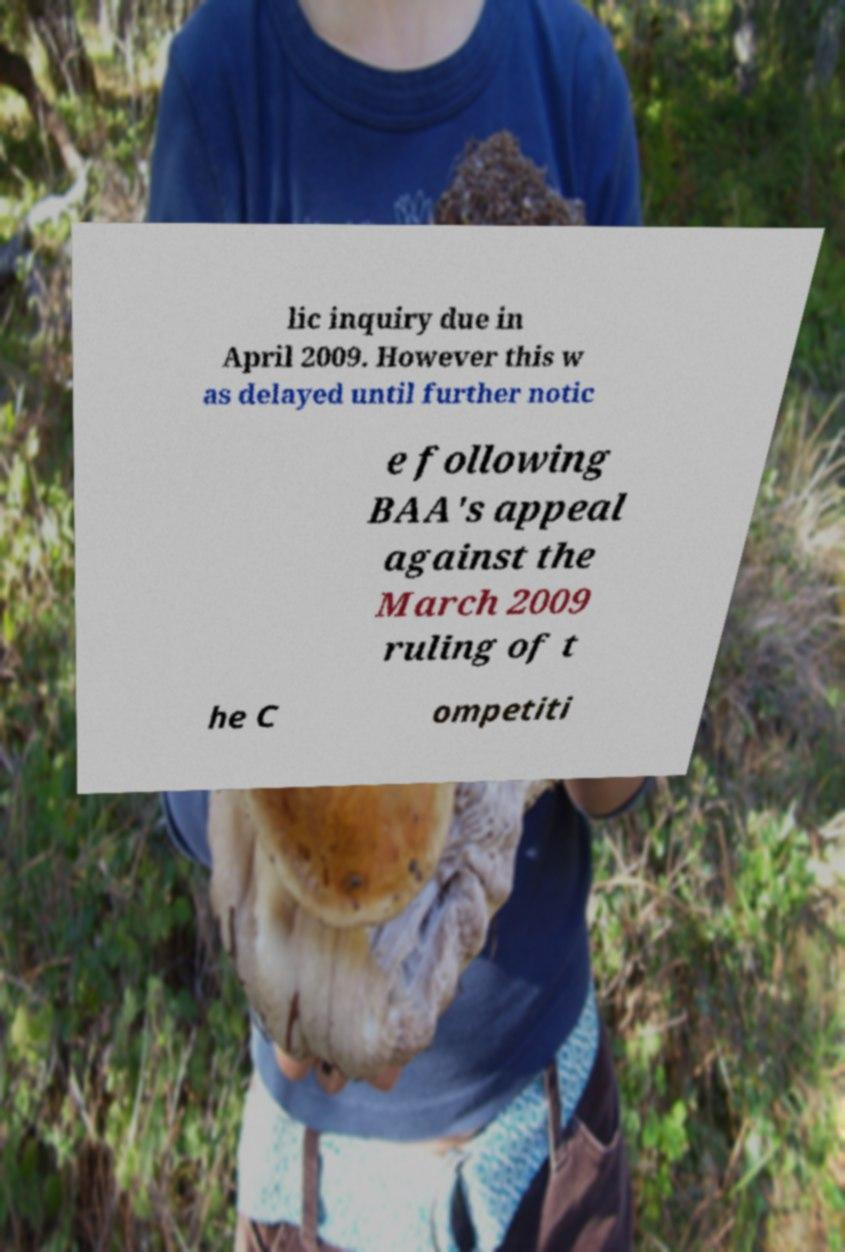What messages or text are displayed in this image? I need them in a readable, typed format. lic inquiry due in April 2009. However this w as delayed until further notic e following BAA's appeal against the March 2009 ruling of t he C ompetiti 